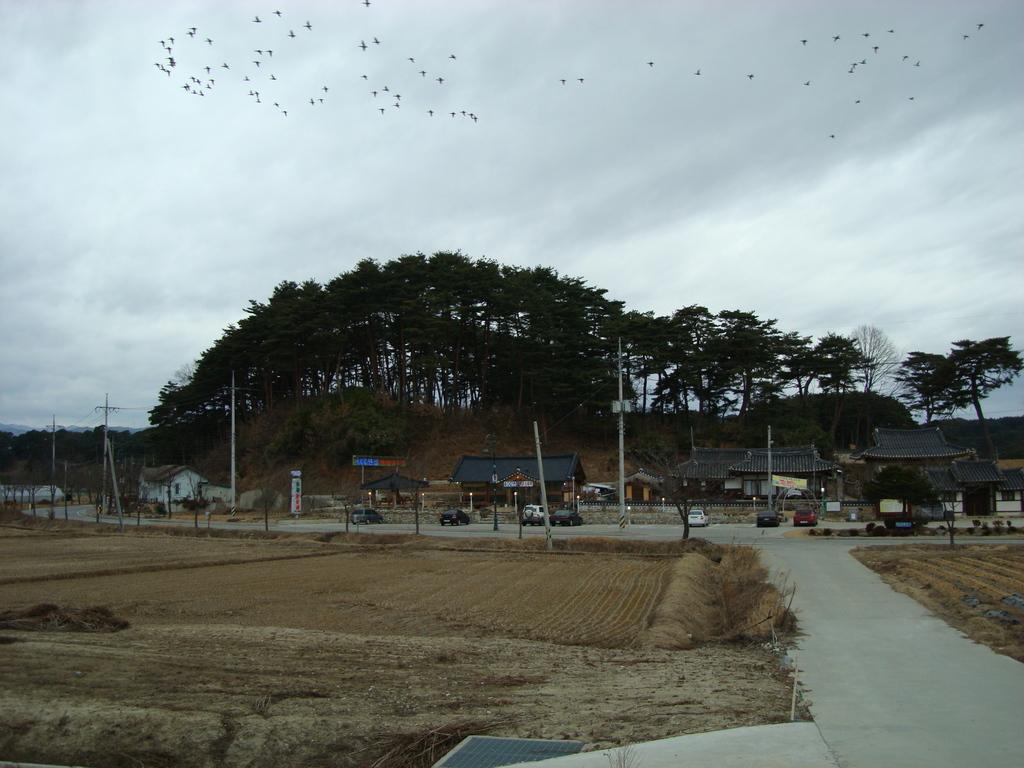Could you give a brief overview of what you see in this image? In this image we can see ground, rods, poles, boards, vehicles, houses, and trees. In the background we can see birds flying in the sky. 